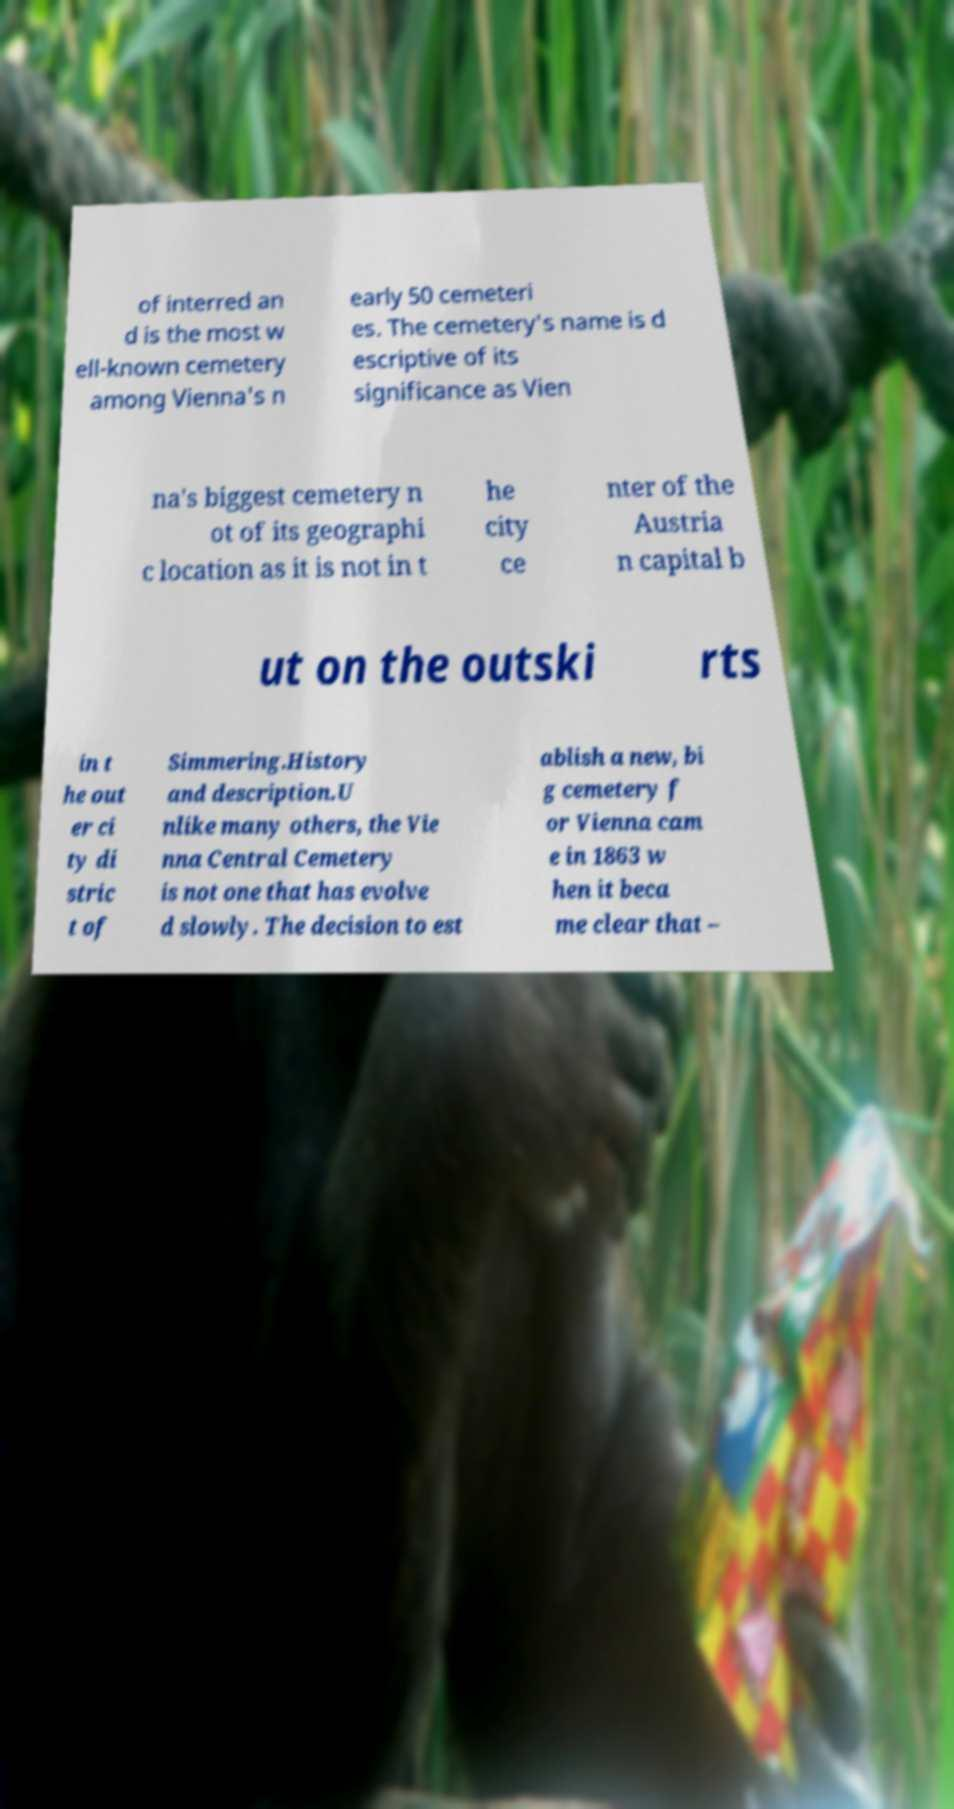For documentation purposes, I need the text within this image transcribed. Could you provide that? of interred an d is the most w ell-known cemetery among Vienna's n early 50 cemeteri es. The cemetery's name is d escriptive of its significance as Vien na's biggest cemetery n ot of its geographi c location as it is not in t he city ce nter of the Austria n capital b ut on the outski rts in t he out er ci ty di stric t of Simmering.History and description.U nlike many others, the Vie nna Central Cemetery is not one that has evolve d slowly. The decision to est ablish a new, bi g cemetery f or Vienna cam e in 1863 w hen it beca me clear that – 